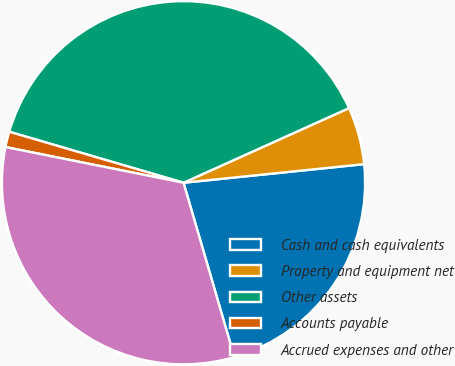Convert chart. <chart><loc_0><loc_0><loc_500><loc_500><pie_chart><fcel>Cash and cash equivalents<fcel>Property and equipment net<fcel>Other assets<fcel>Accounts payable<fcel>Accrued expenses and other<nl><fcel>22.12%<fcel>5.11%<fcel>38.73%<fcel>1.38%<fcel>32.67%<nl></chart> 